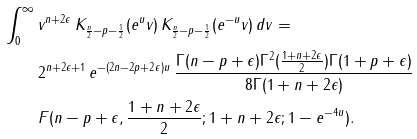Convert formula to latex. <formula><loc_0><loc_0><loc_500><loc_500>\int _ { 0 } ^ { \infty } \, & v ^ { n + 2 \epsilon } \, K _ { \frac { n } { 2 } - p - \frac { 1 } { 2 } } ( e ^ { u } v ) \, K _ { \frac { n } { 2 } - p - \frac { 1 } { 2 } } ( e ^ { - u } v ) \, d v = \\ & 2 ^ { n + 2 \epsilon + 1 } \, e ^ { - ( 2 n - 2 p + 2 \epsilon ) u } \, \frac { \Gamma ( n - p + \epsilon ) \Gamma ^ { 2 } ( \frac { 1 + n + 2 \epsilon } { 2 } ) \Gamma ( 1 + p + \epsilon ) } { 8 \Gamma ( 1 + n + 2 \epsilon ) } \\ & F ( n - p + \epsilon , \frac { 1 + n + 2 \epsilon } { 2 } ; 1 + n + 2 \epsilon ; 1 - e ^ { - 4 u } ) .</formula> 